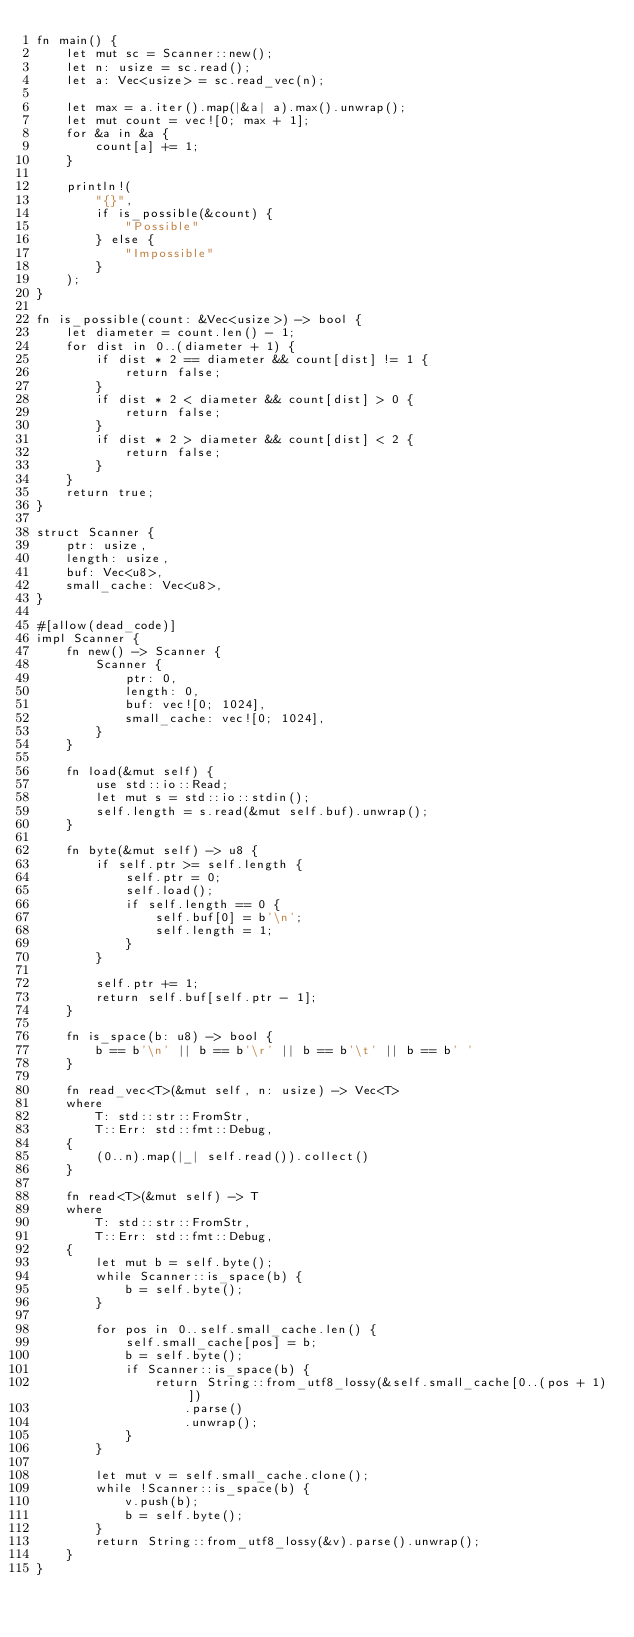Convert code to text. <code><loc_0><loc_0><loc_500><loc_500><_Rust_>fn main() {
    let mut sc = Scanner::new();
    let n: usize = sc.read();
    let a: Vec<usize> = sc.read_vec(n);

    let max = a.iter().map(|&a| a).max().unwrap();
    let mut count = vec![0; max + 1];
    for &a in &a {
        count[a] += 1;
    }

    println!(
        "{}",
        if is_possible(&count) {
            "Possible"
        } else {
            "Impossible"
        }
    );
}

fn is_possible(count: &Vec<usize>) -> bool {
    let diameter = count.len() - 1;
    for dist in 0..(diameter + 1) {
        if dist * 2 == diameter && count[dist] != 1 {
            return false;
        }
        if dist * 2 < diameter && count[dist] > 0 {
            return false;
        }
        if dist * 2 > diameter && count[dist] < 2 {
            return false;
        }
    }
    return true;
}

struct Scanner {
    ptr: usize,
    length: usize,
    buf: Vec<u8>,
    small_cache: Vec<u8>,
}

#[allow(dead_code)]
impl Scanner {
    fn new() -> Scanner {
        Scanner {
            ptr: 0,
            length: 0,
            buf: vec![0; 1024],
            small_cache: vec![0; 1024],
        }
    }

    fn load(&mut self) {
        use std::io::Read;
        let mut s = std::io::stdin();
        self.length = s.read(&mut self.buf).unwrap();
    }

    fn byte(&mut self) -> u8 {
        if self.ptr >= self.length {
            self.ptr = 0;
            self.load();
            if self.length == 0 {
                self.buf[0] = b'\n';
                self.length = 1;
            }
        }

        self.ptr += 1;
        return self.buf[self.ptr - 1];
    }

    fn is_space(b: u8) -> bool {
        b == b'\n' || b == b'\r' || b == b'\t' || b == b' '
    }

    fn read_vec<T>(&mut self, n: usize) -> Vec<T>
    where
        T: std::str::FromStr,
        T::Err: std::fmt::Debug,
    {
        (0..n).map(|_| self.read()).collect()
    }

    fn read<T>(&mut self) -> T
    where
        T: std::str::FromStr,
        T::Err: std::fmt::Debug,
    {
        let mut b = self.byte();
        while Scanner::is_space(b) {
            b = self.byte();
        }

        for pos in 0..self.small_cache.len() {
            self.small_cache[pos] = b;
            b = self.byte();
            if Scanner::is_space(b) {
                return String::from_utf8_lossy(&self.small_cache[0..(pos + 1)])
                    .parse()
                    .unwrap();
            }
        }

        let mut v = self.small_cache.clone();
        while !Scanner::is_space(b) {
            v.push(b);
            b = self.byte();
        }
        return String::from_utf8_lossy(&v).parse().unwrap();
    }
}
</code> 